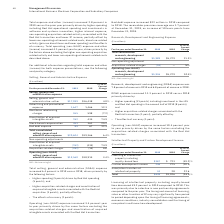According to International Business Machines's financial document, What percentage of total revenue was Research, development and engineering (RD&E) expenses? Research, development and engineering (RD&E) expense was 7.8 percent of revenue in 2019 and 6.8 percent of revenue in 2018.. The document states: "Research, development and engineering (RD&E) expense was 7.8 percent of revenue in 2019 and 6.8 percent of revenue in 2018...." Also, What caused the increase in the RD&E expenses? RD&E expense increased 11.3 percent in 2019 versus 2018 primarily driven by: • Higher spending (11 points) including investment in the z15 and Red Hat spending in the second half of 2019 (8 points); and • Higher acquisition-related charges associated with the Red Hat transaction (1 point); partially offset by • The effects of currency (1 point).. The document states: "RD&E expense increased 11.3 percent in 2019 versus 2018 primarily driven by: • Higher spending (11 points) including investment in the z15 and Red Hat..." Also, What caused the Operating (non-GAAP) expense increase? Operating (non-GAAP) expense increased 10.4 percent year to year primarily driven by the same factors excluding the acquisition-related charges associated with the Red Hat transaction.. The document states: "Operating (non-GAAP) expense increased 10.4 percent year to year primarily driven by the same factors excluding the acquisition-related charges associ..." Also, can you calculate: What was the increase / (decrease) in the Total consolidated research, development and engineering from 2018 to 2019? Based on the calculation: 5,989 - 5,379, the result is 610 (in millions). This is based on the information: "ted research, development and engineering $5,989 $5,379 11.3% nsolidated research, development and engineering $5,989 $5,379 11.3%..." The key data points involved are: 5,379, 5,989. Also, can you calculate: What was the average Acquisition-related charges? To answer this question, I need to perform calculations using the financial data. The calculation is: (-53 + 0) / 2, which equals -26.5 (in millions). This is based on the information: "40 Management Discussion International Business Machines Corporation and Subsidiary Companies Stock-based compensation 453 361 25.2..." The key data points involved are: 0, 53. Also, can you calculate: What was the Operating (non-GAAP) research, development and engineering average? To answer this question, I need to perform calculations using the financial data. The calculation is: (5,936 + 5,379) / 2, which equals 5657.5 (in millions). This is based on the information: "(non-GAAP) research, development and engineering $5,936 $5,379 10.4% AP) research, development and engineering $5,936 $5,379 10.4%..." The key data points involved are: 5,379, 5,936. 